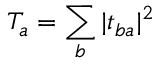<formula> <loc_0><loc_0><loc_500><loc_500>T _ { a } = \sum _ { b } | t _ { b a } | ^ { 2 }</formula> 